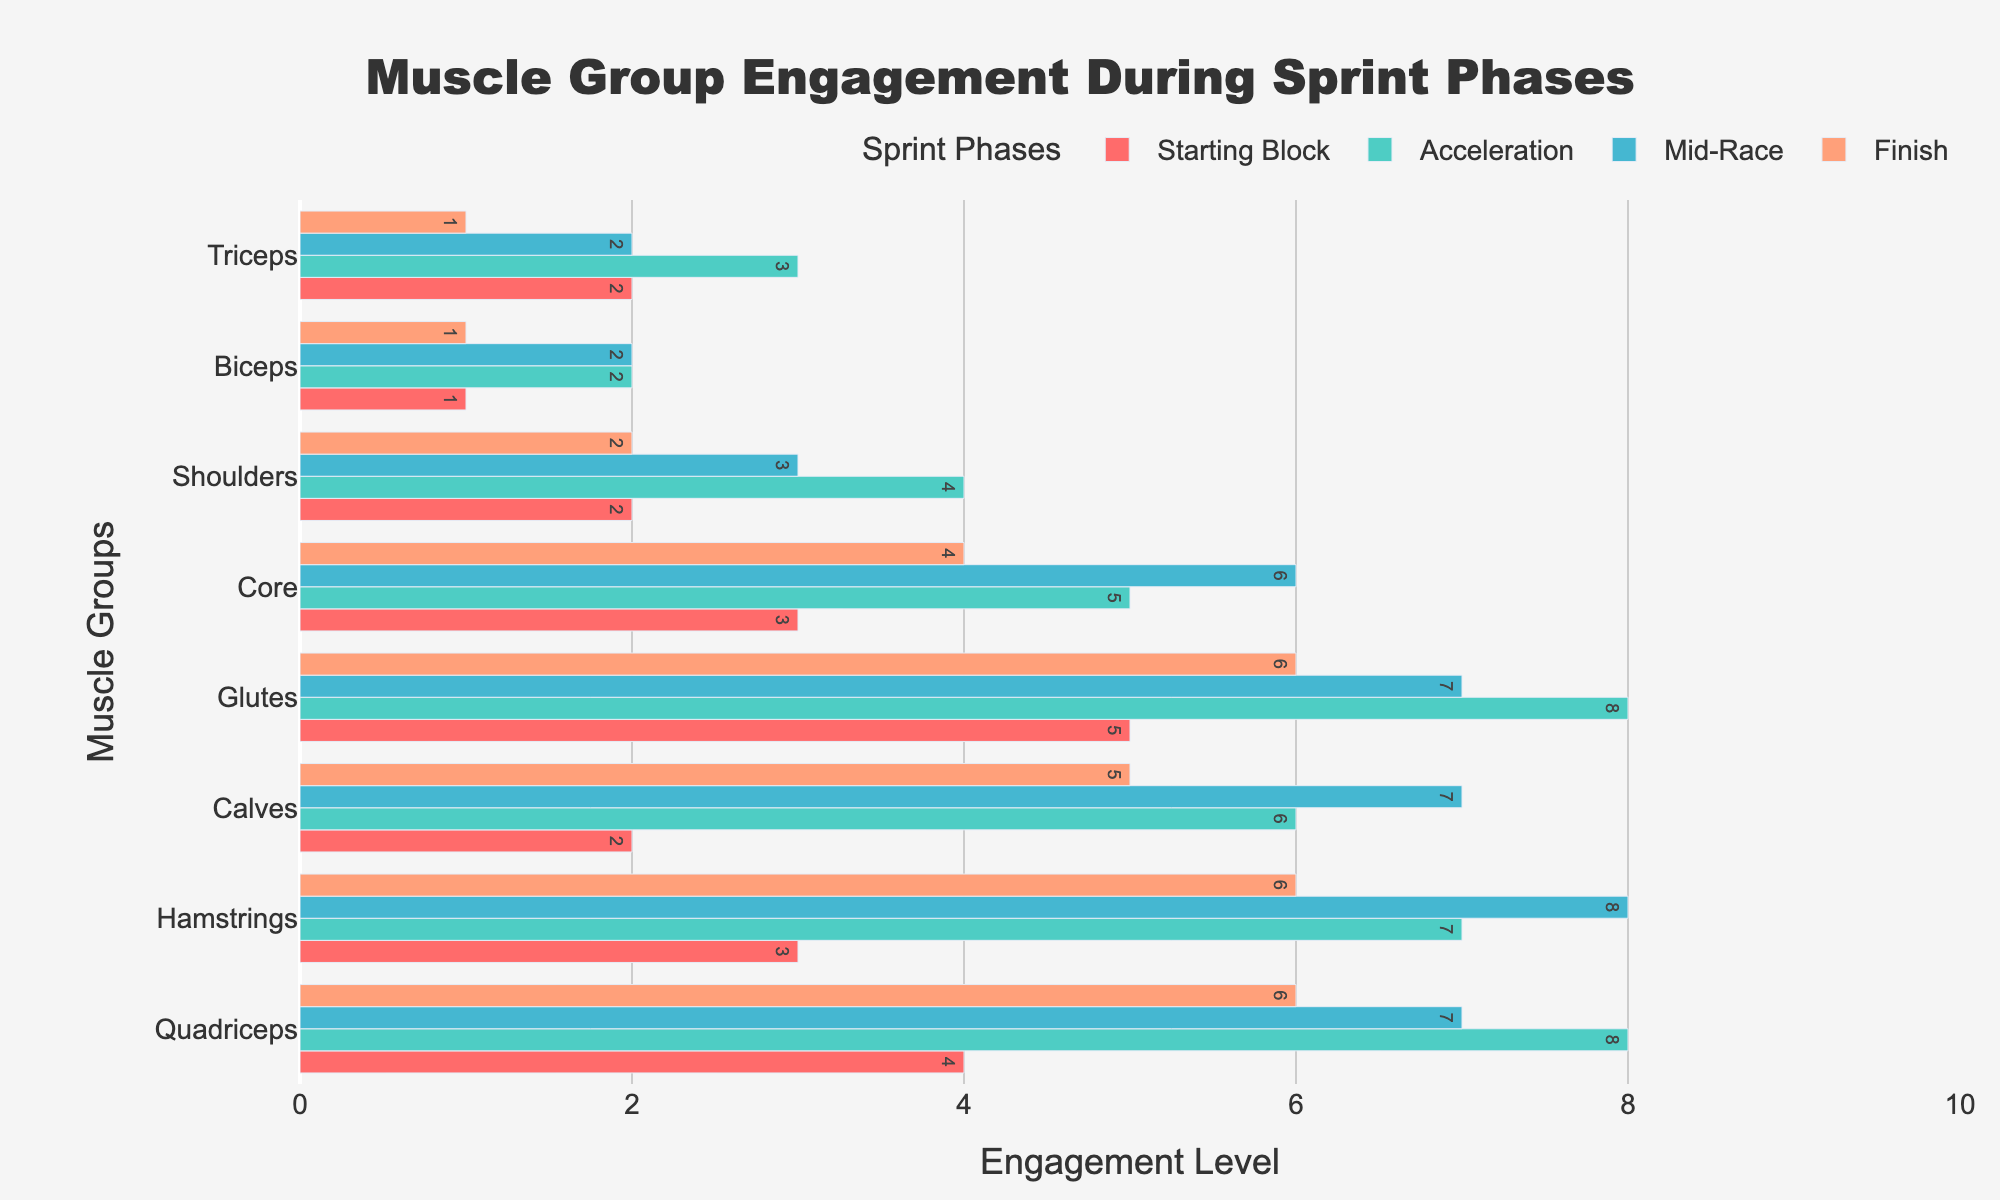What's the title of the figure? The title of the figure is centered at the top and can be read directly.
Answer: Muscle Group Engagement During Sprint Phases What is the highest engagement level for the Hamstrings during the sprint? To find the highest engagement level for the Hamstrings, locate the Hamstrings row and identify the highest value across all sprint phases. The values are 3, 7, 8, and 6; the highest is 8.
Answer: 8 Which muscle group has the lowest engagement during the Mid-Race phase? To determine this, look down the Mid-Race column and find the lowest value. The lowest value listed is 2 for both the Shoulders and Triceps.
Answer: Shoulders, Triceps By how much does the engagement of the Quadriceps increase from the Starting Block phase to the Acceleration phase? The engagement level for the Quadriceps in the Starting Block phase is 4, and in the Acceleration phase, it is 8. The increase is calculated by subtracting 4 from 8.
Answer: 4 What muscle group shows a decline in engagement from Acceleration to Mid-Race phase? Compare the engagement levels from Acceleration to Mid-Race for each muscle group. Look for any decrease: Quadriceps (8 to 7), Glutes (8 to 7), Core (5 to 6), Shoulders (4 to 3), Biceps (2 to 2, no change), Triceps (3 to 2), Hamstrings (7 to 8, increase), and Calves (6 to 7, increase). Quadriceps, Glutes, Shoulders, and Triceps show a decline.
Answer: Quadriceps, Glutes, Shoulders, Triceps Which phase has the highest overall muscle engagement on average? To find the average engagement per phase, sum each column's values and divide by the number of muscle groups (8). The sums are: Starting Block (22), Acceleration (43), Mid-Race (42), and Finish (31). The averages are: Starting Block (22/8 = 2.75), Acceleration (43/8 = 5.375), Mid-Race (42/8 = 5.25), and Finish (31/8 = 3.875). Acceleration has the highest average.
Answer: Acceleration Which muscle group remains the least engaged throughout all phases? To determine this, identify the muscle with the lowest values across all phases and verify that it consistently has low engagement. Biceps has the values 1, 2, 2, and 1, which are the lowest throughout.
Answer: Biceps 